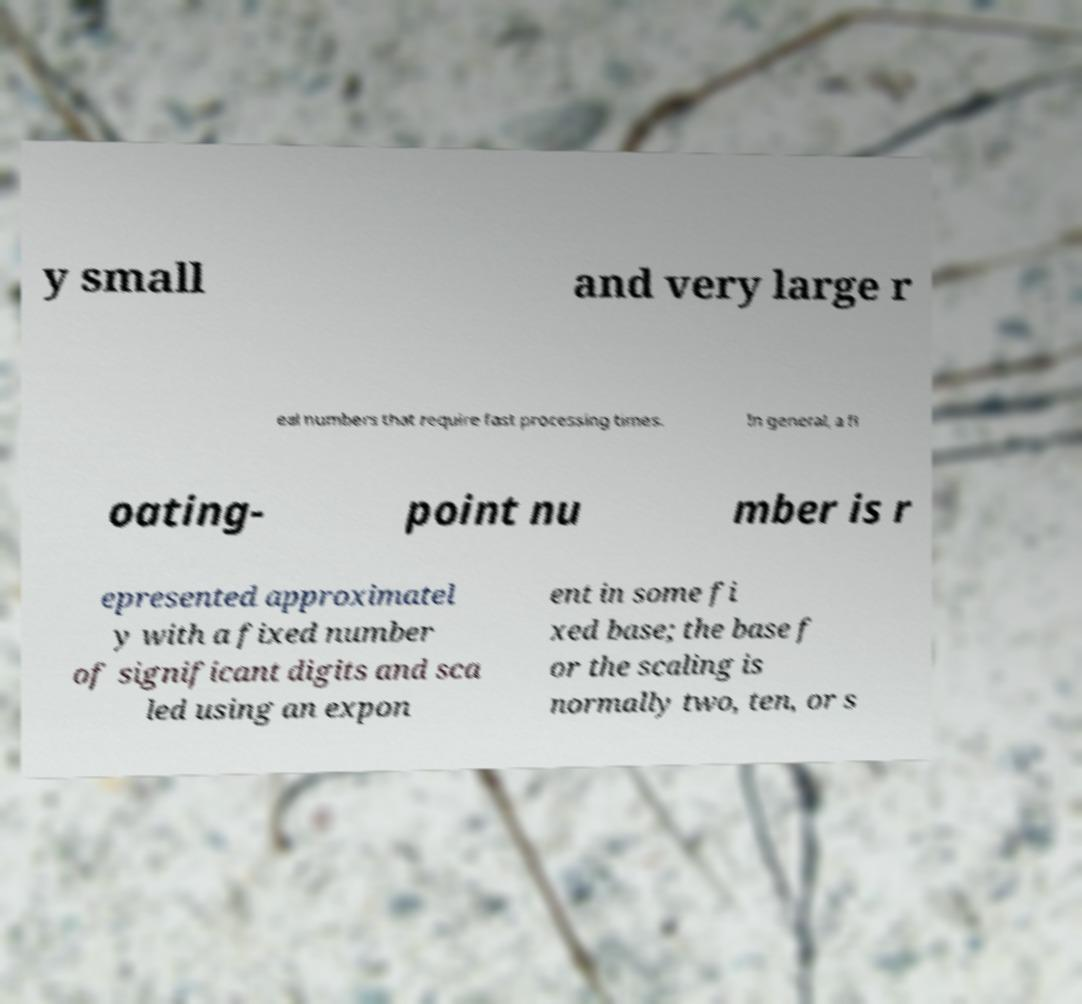For documentation purposes, I need the text within this image transcribed. Could you provide that? y small and very large r eal numbers that require fast processing times. In general, a fl oating- point nu mber is r epresented approximatel y with a fixed number of significant digits and sca led using an expon ent in some fi xed base; the base f or the scaling is normally two, ten, or s 